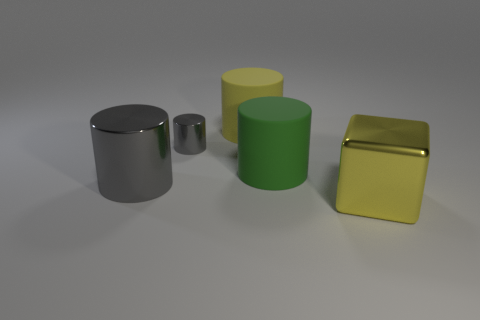Add 5 tiny red rubber spheres. How many objects exist? 10 Subtract all blocks. How many objects are left? 4 Subtract 1 green cylinders. How many objects are left? 4 Subtract all tiny blue cubes. Subtract all large gray objects. How many objects are left? 4 Add 3 big rubber cylinders. How many big rubber cylinders are left? 5 Add 1 yellow objects. How many yellow objects exist? 3 